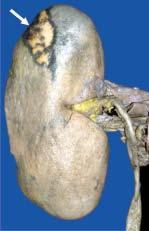how is the central area?
Answer the question using a single word or phrase. Pale 